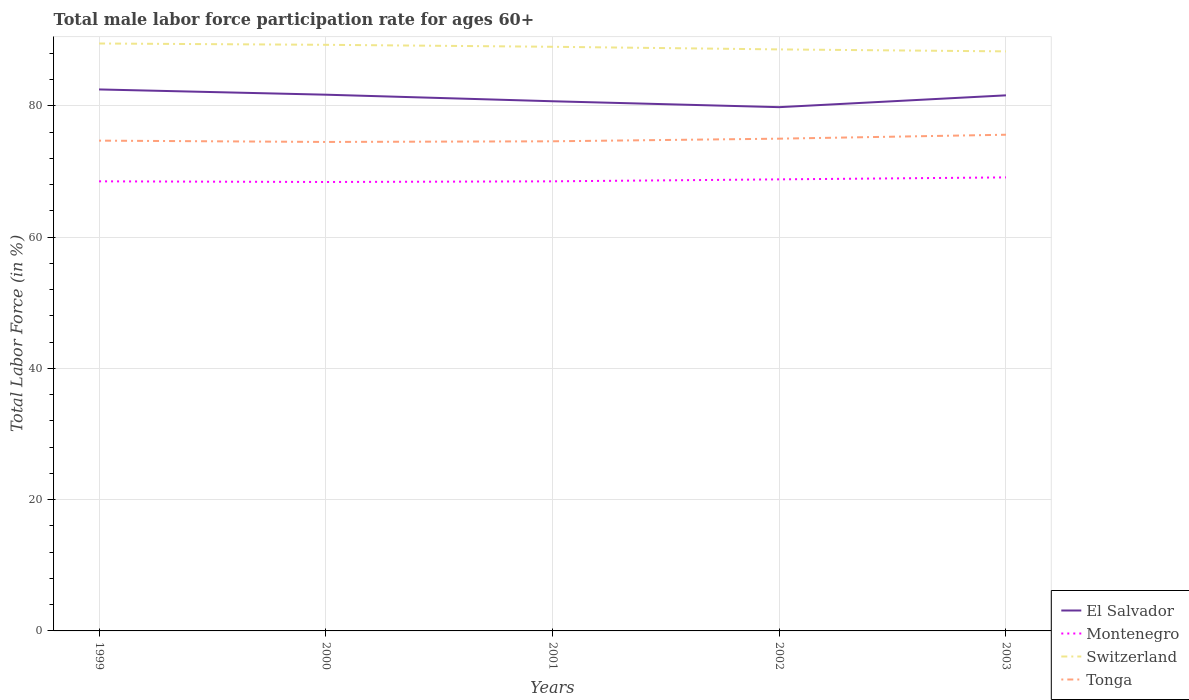Across all years, what is the maximum male labor force participation rate in El Salvador?
Your answer should be compact. 79.8. What is the total male labor force participation rate in El Salvador in the graph?
Provide a short and direct response. 2.7. What is the difference between the highest and the second highest male labor force participation rate in Switzerland?
Ensure brevity in your answer.  1.2. What is the difference between the highest and the lowest male labor force participation rate in Switzerland?
Your answer should be compact. 3. Is the male labor force participation rate in El Salvador strictly greater than the male labor force participation rate in Switzerland over the years?
Provide a short and direct response. Yes. How many lines are there?
Offer a terse response. 4. Does the graph contain any zero values?
Make the answer very short. No. Does the graph contain grids?
Give a very brief answer. Yes. Where does the legend appear in the graph?
Provide a short and direct response. Bottom right. How are the legend labels stacked?
Give a very brief answer. Vertical. What is the title of the graph?
Keep it short and to the point. Total male labor force participation rate for ages 60+. What is the label or title of the Y-axis?
Ensure brevity in your answer.  Total Labor Force (in %). What is the Total Labor Force (in %) in El Salvador in 1999?
Offer a terse response. 82.5. What is the Total Labor Force (in %) in Montenegro in 1999?
Ensure brevity in your answer.  68.5. What is the Total Labor Force (in %) of Switzerland in 1999?
Your answer should be compact. 89.5. What is the Total Labor Force (in %) in Tonga in 1999?
Provide a short and direct response. 74.7. What is the Total Labor Force (in %) of El Salvador in 2000?
Offer a very short reply. 81.7. What is the Total Labor Force (in %) in Montenegro in 2000?
Your answer should be compact. 68.4. What is the Total Labor Force (in %) of Switzerland in 2000?
Keep it short and to the point. 89.3. What is the Total Labor Force (in %) of Tonga in 2000?
Offer a very short reply. 74.5. What is the Total Labor Force (in %) of El Salvador in 2001?
Provide a succinct answer. 80.7. What is the Total Labor Force (in %) in Montenegro in 2001?
Ensure brevity in your answer.  68.5. What is the Total Labor Force (in %) in Switzerland in 2001?
Ensure brevity in your answer.  89. What is the Total Labor Force (in %) in Tonga in 2001?
Make the answer very short. 74.6. What is the Total Labor Force (in %) of El Salvador in 2002?
Keep it short and to the point. 79.8. What is the Total Labor Force (in %) of Montenegro in 2002?
Provide a succinct answer. 68.8. What is the Total Labor Force (in %) in Switzerland in 2002?
Your response must be concise. 88.6. What is the Total Labor Force (in %) in El Salvador in 2003?
Your answer should be very brief. 81.6. What is the Total Labor Force (in %) of Montenegro in 2003?
Your answer should be compact. 69.1. What is the Total Labor Force (in %) in Switzerland in 2003?
Offer a terse response. 88.3. What is the Total Labor Force (in %) in Tonga in 2003?
Offer a very short reply. 75.6. Across all years, what is the maximum Total Labor Force (in %) of El Salvador?
Make the answer very short. 82.5. Across all years, what is the maximum Total Labor Force (in %) of Montenegro?
Ensure brevity in your answer.  69.1. Across all years, what is the maximum Total Labor Force (in %) of Switzerland?
Offer a very short reply. 89.5. Across all years, what is the maximum Total Labor Force (in %) in Tonga?
Give a very brief answer. 75.6. Across all years, what is the minimum Total Labor Force (in %) in El Salvador?
Give a very brief answer. 79.8. Across all years, what is the minimum Total Labor Force (in %) of Montenegro?
Your response must be concise. 68.4. Across all years, what is the minimum Total Labor Force (in %) in Switzerland?
Your answer should be very brief. 88.3. Across all years, what is the minimum Total Labor Force (in %) of Tonga?
Keep it short and to the point. 74.5. What is the total Total Labor Force (in %) in El Salvador in the graph?
Your answer should be very brief. 406.3. What is the total Total Labor Force (in %) in Montenegro in the graph?
Ensure brevity in your answer.  343.3. What is the total Total Labor Force (in %) of Switzerland in the graph?
Offer a terse response. 444.7. What is the total Total Labor Force (in %) in Tonga in the graph?
Provide a succinct answer. 374.4. What is the difference between the Total Labor Force (in %) in Montenegro in 1999 and that in 2000?
Make the answer very short. 0.1. What is the difference between the Total Labor Force (in %) in Tonga in 1999 and that in 2000?
Your answer should be very brief. 0.2. What is the difference between the Total Labor Force (in %) of Tonga in 1999 and that in 2001?
Provide a succinct answer. 0.1. What is the difference between the Total Labor Force (in %) in El Salvador in 1999 and that in 2002?
Make the answer very short. 2.7. What is the difference between the Total Labor Force (in %) in El Salvador in 1999 and that in 2003?
Your answer should be compact. 0.9. What is the difference between the Total Labor Force (in %) of El Salvador in 2000 and that in 2001?
Ensure brevity in your answer.  1. What is the difference between the Total Labor Force (in %) of Montenegro in 2000 and that in 2001?
Your answer should be very brief. -0.1. What is the difference between the Total Labor Force (in %) of Switzerland in 2000 and that in 2001?
Your response must be concise. 0.3. What is the difference between the Total Labor Force (in %) of Tonga in 2000 and that in 2001?
Provide a short and direct response. -0.1. What is the difference between the Total Labor Force (in %) of Montenegro in 2000 and that in 2002?
Your response must be concise. -0.4. What is the difference between the Total Labor Force (in %) of El Salvador in 2000 and that in 2003?
Your response must be concise. 0.1. What is the difference between the Total Labor Force (in %) in Tonga in 2000 and that in 2003?
Your answer should be very brief. -1.1. What is the difference between the Total Labor Force (in %) in Switzerland in 2001 and that in 2002?
Give a very brief answer. 0.4. What is the difference between the Total Labor Force (in %) of Tonga in 2001 and that in 2002?
Ensure brevity in your answer.  -0.4. What is the difference between the Total Labor Force (in %) of El Salvador in 2001 and that in 2003?
Offer a terse response. -0.9. What is the difference between the Total Labor Force (in %) of Montenegro in 2001 and that in 2003?
Give a very brief answer. -0.6. What is the difference between the Total Labor Force (in %) of El Salvador in 2002 and that in 2003?
Ensure brevity in your answer.  -1.8. What is the difference between the Total Labor Force (in %) of Montenegro in 2002 and that in 2003?
Your answer should be very brief. -0.3. What is the difference between the Total Labor Force (in %) of El Salvador in 1999 and the Total Labor Force (in %) of Switzerland in 2000?
Your answer should be very brief. -6.8. What is the difference between the Total Labor Force (in %) in Montenegro in 1999 and the Total Labor Force (in %) in Switzerland in 2000?
Give a very brief answer. -20.8. What is the difference between the Total Labor Force (in %) in El Salvador in 1999 and the Total Labor Force (in %) in Switzerland in 2001?
Give a very brief answer. -6.5. What is the difference between the Total Labor Force (in %) in Montenegro in 1999 and the Total Labor Force (in %) in Switzerland in 2001?
Offer a terse response. -20.5. What is the difference between the Total Labor Force (in %) in Switzerland in 1999 and the Total Labor Force (in %) in Tonga in 2001?
Your response must be concise. 14.9. What is the difference between the Total Labor Force (in %) in El Salvador in 1999 and the Total Labor Force (in %) in Montenegro in 2002?
Your answer should be very brief. 13.7. What is the difference between the Total Labor Force (in %) in El Salvador in 1999 and the Total Labor Force (in %) in Switzerland in 2002?
Keep it short and to the point. -6.1. What is the difference between the Total Labor Force (in %) of Montenegro in 1999 and the Total Labor Force (in %) of Switzerland in 2002?
Keep it short and to the point. -20.1. What is the difference between the Total Labor Force (in %) in Montenegro in 1999 and the Total Labor Force (in %) in Tonga in 2002?
Your answer should be compact. -6.5. What is the difference between the Total Labor Force (in %) of El Salvador in 1999 and the Total Labor Force (in %) of Montenegro in 2003?
Provide a succinct answer. 13.4. What is the difference between the Total Labor Force (in %) of El Salvador in 1999 and the Total Labor Force (in %) of Switzerland in 2003?
Your answer should be very brief. -5.8. What is the difference between the Total Labor Force (in %) in Montenegro in 1999 and the Total Labor Force (in %) in Switzerland in 2003?
Offer a terse response. -19.8. What is the difference between the Total Labor Force (in %) in Montenegro in 1999 and the Total Labor Force (in %) in Tonga in 2003?
Provide a succinct answer. -7.1. What is the difference between the Total Labor Force (in %) of El Salvador in 2000 and the Total Labor Force (in %) of Switzerland in 2001?
Ensure brevity in your answer.  -7.3. What is the difference between the Total Labor Force (in %) in El Salvador in 2000 and the Total Labor Force (in %) in Tonga in 2001?
Ensure brevity in your answer.  7.1. What is the difference between the Total Labor Force (in %) of Montenegro in 2000 and the Total Labor Force (in %) of Switzerland in 2001?
Make the answer very short. -20.6. What is the difference between the Total Labor Force (in %) in El Salvador in 2000 and the Total Labor Force (in %) in Montenegro in 2002?
Your answer should be very brief. 12.9. What is the difference between the Total Labor Force (in %) of Montenegro in 2000 and the Total Labor Force (in %) of Switzerland in 2002?
Provide a short and direct response. -20.2. What is the difference between the Total Labor Force (in %) of Montenegro in 2000 and the Total Labor Force (in %) of Tonga in 2002?
Make the answer very short. -6.6. What is the difference between the Total Labor Force (in %) of Switzerland in 2000 and the Total Labor Force (in %) of Tonga in 2002?
Your answer should be compact. 14.3. What is the difference between the Total Labor Force (in %) in El Salvador in 2000 and the Total Labor Force (in %) in Tonga in 2003?
Your answer should be very brief. 6.1. What is the difference between the Total Labor Force (in %) in Montenegro in 2000 and the Total Labor Force (in %) in Switzerland in 2003?
Your answer should be very brief. -19.9. What is the difference between the Total Labor Force (in %) of Switzerland in 2000 and the Total Labor Force (in %) of Tonga in 2003?
Offer a terse response. 13.7. What is the difference between the Total Labor Force (in %) of El Salvador in 2001 and the Total Labor Force (in %) of Montenegro in 2002?
Your response must be concise. 11.9. What is the difference between the Total Labor Force (in %) in El Salvador in 2001 and the Total Labor Force (in %) in Tonga in 2002?
Ensure brevity in your answer.  5.7. What is the difference between the Total Labor Force (in %) in Montenegro in 2001 and the Total Labor Force (in %) in Switzerland in 2002?
Your answer should be compact. -20.1. What is the difference between the Total Labor Force (in %) of Switzerland in 2001 and the Total Labor Force (in %) of Tonga in 2002?
Keep it short and to the point. 14. What is the difference between the Total Labor Force (in %) in El Salvador in 2001 and the Total Labor Force (in %) in Montenegro in 2003?
Give a very brief answer. 11.6. What is the difference between the Total Labor Force (in %) of Montenegro in 2001 and the Total Labor Force (in %) of Switzerland in 2003?
Keep it short and to the point. -19.8. What is the difference between the Total Labor Force (in %) of El Salvador in 2002 and the Total Labor Force (in %) of Montenegro in 2003?
Keep it short and to the point. 10.7. What is the difference between the Total Labor Force (in %) in El Salvador in 2002 and the Total Labor Force (in %) in Switzerland in 2003?
Keep it short and to the point. -8.5. What is the difference between the Total Labor Force (in %) of El Salvador in 2002 and the Total Labor Force (in %) of Tonga in 2003?
Provide a short and direct response. 4.2. What is the difference between the Total Labor Force (in %) of Montenegro in 2002 and the Total Labor Force (in %) of Switzerland in 2003?
Ensure brevity in your answer.  -19.5. What is the difference between the Total Labor Force (in %) of Montenegro in 2002 and the Total Labor Force (in %) of Tonga in 2003?
Make the answer very short. -6.8. What is the average Total Labor Force (in %) in El Salvador per year?
Your answer should be very brief. 81.26. What is the average Total Labor Force (in %) in Montenegro per year?
Keep it short and to the point. 68.66. What is the average Total Labor Force (in %) of Switzerland per year?
Your answer should be very brief. 88.94. What is the average Total Labor Force (in %) in Tonga per year?
Offer a very short reply. 74.88. In the year 1999, what is the difference between the Total Labor Force (in %) of El Salvador and Total Labor Force (in %) of Tonga?
Give a very brief answer. 7.8. In the year 1999, what is the difference between the Total Labor Force (in %) in Montenegro and Total Labor Force (in %) in Switzerland?
Ensure brevity in your answer.  -21. In the year 1999, what is the difference between the Total Labor Force (in %) of Switzerland and Total Labor Force (in %) of Tonga?
Provide a succinct answer. 14.8. In the year 2000, what is the difference between the Total Labor Force (in %) of El Salvador and Total Labor Force (in %) of Montenegro?
Offer a terse response. 13.3. In the year 2000, what is the difference between the Total Labor Force (in %) in El Salvador and Total Labor Force (in %) in Switzerland?
Give a very brief answer. -7.6. In the year 2000, what is the difference between the Total Labor Force (in %) in Montenegro and Total Labor Force (in %) in Switzerland?
Ensure brevity in your answer.  -20.9. In the year 2001, what is the difference between the Total Labor Force (in %) of El Salvador and Total Labor Force (in %) of Switzerland?
Your answer should be very brief. -8.3. In the year 2001, what is the difference between the Total Labor Force (in %) of El Salvador and Total Labor Force (in %) of Tonga?
Provide a succinct answer. 6.1. In the year 2001, what is the difference between the Total Labor Force (in %) in Montenegro and Total Labor Force (in %) in Switzerland?
Keep it short and to the point. -20.5. In the year 2001, what is the difference between the Total Labor Force (in %) in Montenegro and Total Labor Force (in %) in Tonga?
Your response must be concise. -6.1. In the year 2002, what is the difference between the Total Labor Force (in %) of El Salvador and Total Labor Force (in %) of Montenegro?
Give a very brief answer. 11. In the year 2002, what is the difference between the Total Labor Force (in %) of El Salvador and Total Labor Force (in %) of Switzerland?
Provide a succinct answer. -8.8. In the year 2002, what is the difference between the Total Labor Force (in %) of El Salvador and Total Labor Force (in %) of Tonga?
Offer a very short reply. 4.8. In the year 2002, what is the difference between the Total Labor Force (in %) in Montenegro and Total Labor Force (in %) in Switzerland?
Provide a succinct answer. -19.8. In the year 2002, what is the difference between the Total Labor Force (in %) of Montenegro and Total Labor Force (in %) of Tonga?
Offer a terse response. -6.2. In the year 2002, what is the difference between the Total Labor Force (in %) in Switzerland and Total Labor Force (in %) in Tonga?
Provide a succinct answer. 13.6. In the year 2003, what is the difference between the Total Labor Force (in %) of El Salvador and Total Labor Force (in %) of Switzerland?
Offer a very short reply. -6.7. In the year 2003, what is the difference between the Total Labor Force (in %) of El Salvador and Total Labor Force (in %) of Tonga?
Keep it short and to the point. 6. In the year 2003, what is the difference between the Total Labor Force (in %) in Montenegro and Total Labor Force (in %) in Switzerland?
Ensure brevity in your answer.  -19.2. What is the ratio of the Total Labor Force (in %) in El Salvador in 1999 to that in 2000?
Ensure brevity in your answer.  1.01. What is the ratio of the Total Labor Force (in %) in Montenegro in 1999 to that in 2000?
Ensure brevity in your answer.  1. What is the ratio of the Total Labor Force (in %) in El Salvador in 1999 to that in 2001?
Offer a very short reply. 1.02. What is the ratio of the Total Labor Force (in %) in Switzerland in 1999 to that in 2001?
Give a very brief answer. 1.01. What is the ratio of the Total Labor Force (in %) of Tonga in 1999 to that in 2001?
Keep it short and to the point. 1. What is the ratio of the Total Labor Force (in %) of El Salvador in 1999 to that in 2002?
Provide a succinct answer. 1.03. What is the ratio of the Total Labor Force (in %) of Montenegro in 1999 to that in 2002?
Keep it short and to the point. 1. What is the ratio of the Total Labor Force (in %) in Switzerland in 1999 to that in 2002?
Make the answer very short. 1.01. What is the ratio of the Total Labor Force (in %) in Tonga in 1999 to that in 2002?
Provide a short and direct response. 1. What is the ratio of the Total Labor Force (in %) in El Salvador in 1999 to that in 2003?
Offer a terse response. 1.01. What is the ratio of the Total Labor Force (in %) of Montenegro in 1999 to that in 2003?
Make the answer very short. 0.99. What is the ratio of the Total Labor Force (in %) of Switzerland in 1999 to that in 2003?
Ensure brevity in your answer.  1.01. What is the ratio of the Total Labor Force (in %) in El Salvador in 2000 to that in 2001?
Keep it short and to the point. 1.01. What is the ratio of the Total Labor Force (in %) in El Salvador in 2000 to that in 2002?
Keep it short and to the point. 1.02. What is the ratio of the Total Labor Force (in %) of Montenegro in 2000 to that in 2002?
Ensure brevity in your answer.  0.99. What is the ratio of the Total Labor Force (in %) of Switzerland in 2000 to that in 2002?
Your response must be concise. 1.01. What is the ratio of the Total Labor Force (in %) in Tonga in 2000 to that in 2002?
Offer a terse response. 0.99. What is the ratio of the Total Labor Force (in %) of Montenegro in 2000 to that in 2003?
Ensure brevity in your answer.  0.99. What is the ratio of the Total Labor Force (in %) of Switzerland in 2000 to that in 2003?
Give a very brief answer. 1.01. What is the ratio of the Total Labor Force (in %) of Tonga in 2000 to that in 2003?
Ensure brevity in your answer.  0.99. What is the ratio of the Total Labor Force (in %) in El Salvador in 2001 to that in 2002?
Keep it short and to the point. 1.01. What is the ratio of the Total Labor Force (in %) of Switzerland in 2001 to that in 2003?
Your response must be concise. 1.01. What is the ratio of the Total Labor Force (in %) of El Salvador in 2002 to that in 2003?
Provide a short and direct response. 0.98. What is the ratio of the Total Labor Force (in %) in Switzerland in 2002 to that in 2003?
Ensure brevity in your answer.  1. What is the difference between the highest and the second highest Total Labor Force (in %) in El Salvador?
Provide a short and direct response. 0.8. What is the difference between the highest and the second highest Total Labor Force (in %) in Switzerland?
Give a very brief answer. 0.2. What is the difference between the highest and the second highest Total Labor Force (in %) in Tonga?
Give a very brief answer. 0.6. What is the difference between the highest and the lowest Total Labor Force (in %) of El Salvador?
Make the answer very short. 2.7. What is the difference between the highest and the lowest Total Labor Force (in %) of Switzerland?
Your answer should be very brief. 1.2. 